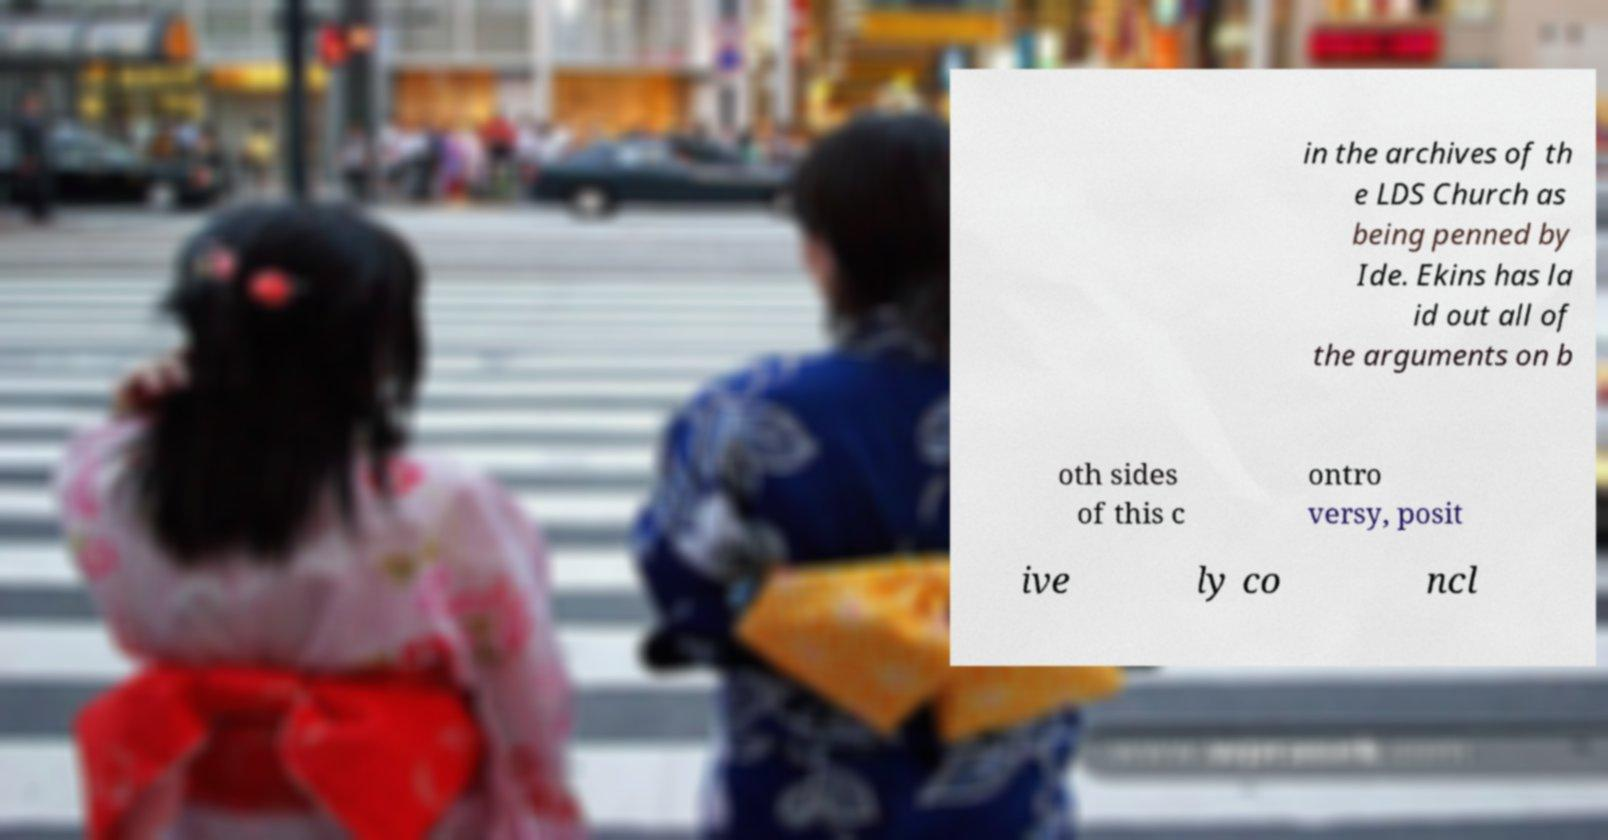I need the written content from this picture converted into text. Can you do that? in the archives of th e LDS Church as being penned by Ide. Ekins has la id out all of the arguments on b oth sides of this c ontro versy, posit ive ly co ncl 